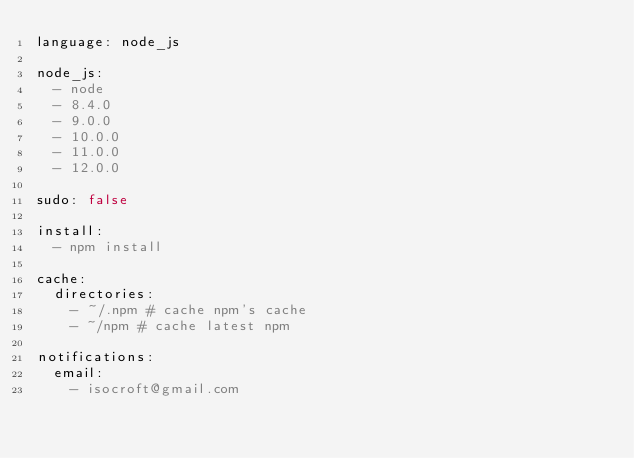Convert code to text. <code><loc_0><loc_0><loc_500><loc_500><_YAML_>language: node_js

node_js:
  - node
  - 8.4.0
  - 9.0.0
  - 10.0.0
  - 11.0.0
  - 12.0.0
  
sudo: false

install:
  - npm install
  
cache:
  directories:
    - ~/.npm # cache npm's cache
    - ~/npm # cache latest npm

notifications:
  email: 
    - isocroft@gmail.com</code> 